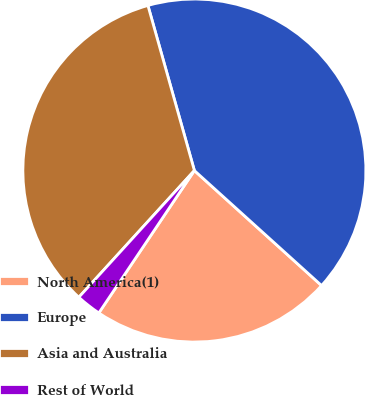<chart> <loc_0><loc_0><loc_500><loc_500><pie_chart><fcel>North America(1)<fcel>Europe<fcel>Asia and Australia<fcel>Rest of World<nl><fcel>22.71%<fcel>41.07%<fcel>33.87%<fcel>2.36%<nl></chart> 